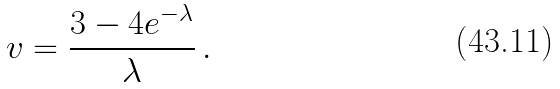Convert formula to latex. <formula><loc_0><loc_0><loc_500><loc_500>v = \frac { 3 - 4 e ^ { - \lambda } } { \lambda } \, .</formula> 